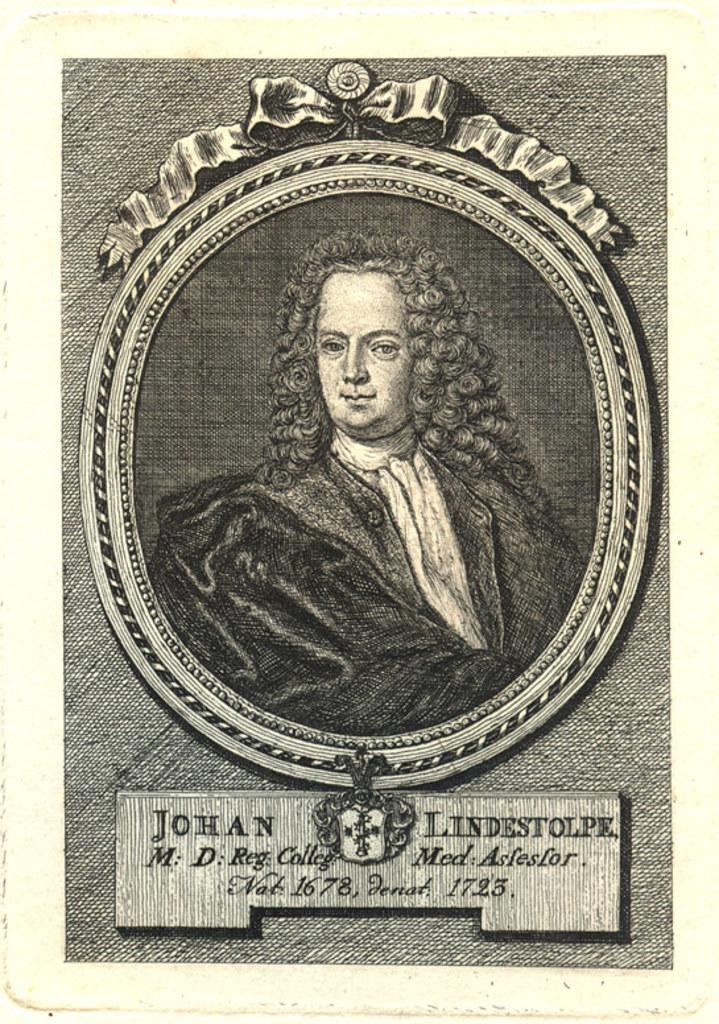What is the main subject of the image? The main subject of the image is a portrait painting of a person. Can you describe any additional details in the image? Yes, there are details below the portrait. How many sisters does the person in the portrait have? There is no information about the person's sisters in the image, so we cannot determine the number of sisters. Can you describe the sea in the image? There is no sea present in the image; it is a portrait painting of a person with details below the portrait. 